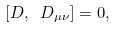Convert formula to latex. <formula><loc_0><loc_0><loc_500><loc_500>[ D , \ D _ { \mu \nu } ] = 0 ,</formula> 